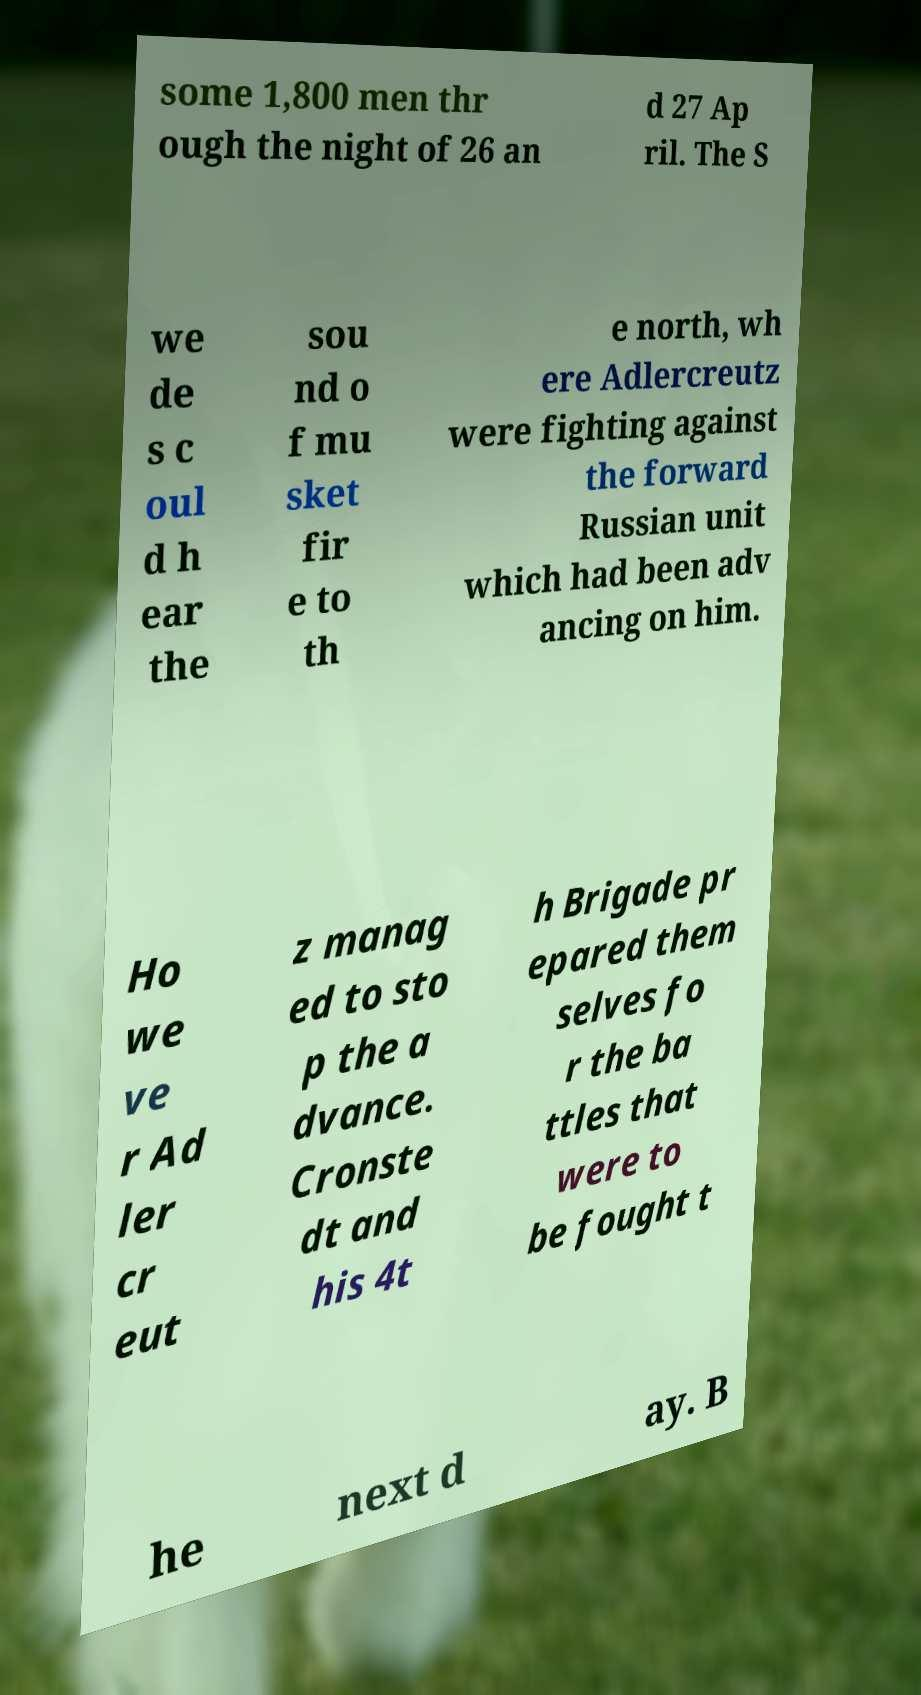What messages or text are displayed in this image? I need them in a readable, typed format. some 1,800 men thr ough the night of 26 an d 27 Ap ril. The S we de s c oul d h ear the sou nd o f mu sket fir e to th e north, wh ere Adlercreutz were fighting against the forward Russian unit which had been adv ancing on him. Ho we ve r Ad ler cr eut z manag ed to sto p the a dvance. Cronste dt and his 4t h Brigade pr epared them selves fo r the ba ttles that were to be fought t he next d ay. B 